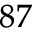<formula> <loc_0><loc_0><loc_500><loc_500>^ { 8 7 }</formula> 